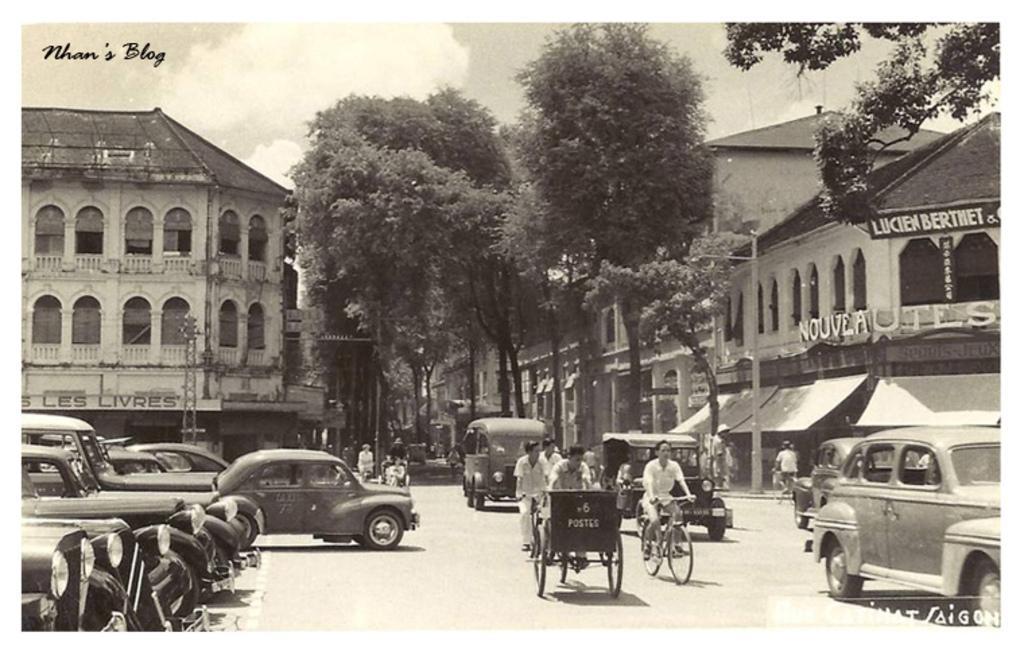In one or two sentences, can you explain what this image depicts? In this picture there is a black and white photography. In the front there is a road with some persons riding the cycle. Behind there is a white color building with roofing tiles and some trees. 